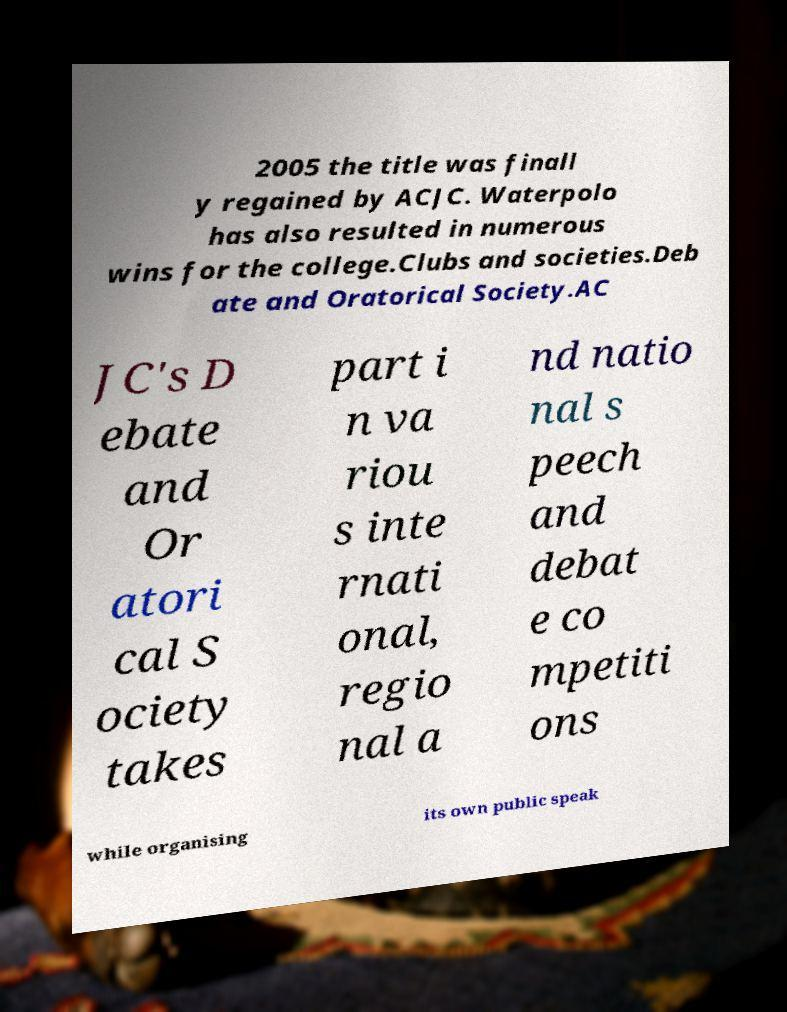Can you accurately transcribe the text from the provided image for me? 2005 the title was finall y regained by ACJC. Waterpolo has also resulted in numerous wins for the college.Clubs and societies.Deb ate and Oratorical Society.AC JC's D ebate and Or atori cal S ociety takes part i n va riou s inte rnati onal, regio nal a nd natio nal s peech and debat e co mpetiti ons while organising its own public speak 